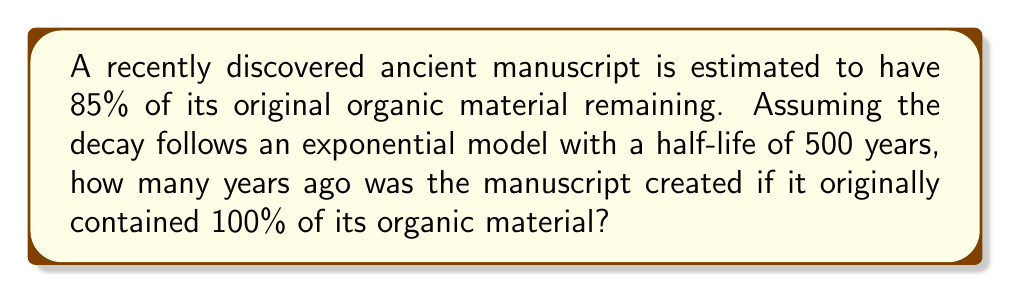Could you help me with this problem? Let's approach this step-by-step using the exponential decay function:

1) The general form of exponential decay is:

   $$ N(t) = N_0 e^{-\lambda t} $$

   Where $N(t)$ is the amount at time $t$, $N_0$ is the initial amount, and $\lambda$ is the decay constant.

2) We're given that 85% of the original material remains, so:

   $$ \frac{N(t)}{N_0} = 0.85 $$

3) We need to find $\lambda$ using the half-life. The half-life $t_{1/2}$ is related to $\lambda$ by:

   $$ t_{1/2} = \frac{\ln(2)}{\lambda} $$

4) Solving for $\lambda$:

   $$ \lambda = \frac{\ln(2)}{t_{1/2}} = \frac{\ln(2)}{500} $$

5) Now we can set up our equation:

   $$ 0.85 = e^{-(\frac{\ln(2)}{500})t} $$

6) Taking the natural log of both sides:

   $$ \ln(0.85) = -\frac{\ln(2)}{500}t $$

7) Solving for $t$:

   $$ t = -\frac{500 \ln(0.85)}{\ln(2)} \approx 119.4 $$

Therefore, the manuscript was created approximately 119 years ago.
Answer: 119 years 